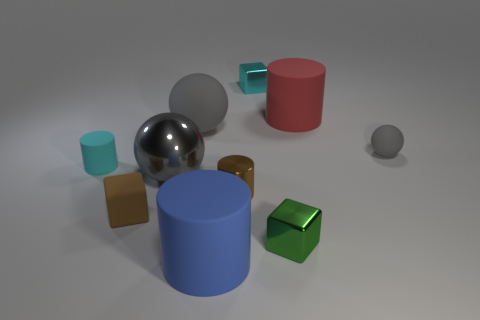There is a rubber cube that is the same color as the small metal cylinder; what size is it?
Offer a very short reply. Small. There is a tiny matte object that is the same color as the shiny cylinder; what shape is it?
Ensure brevity in your answer.  Cube. There is a gray ball that is right of the large cylinder to the left of the tiny brown metallic cylinder; are there any small metallic things that are behind it?
Provide a succinct answer. Yes. There is a red matte object that is the same size as the blue rubber cylinder; what shape is it?
Your response must be concise. Cylinder. Is there a rubber ball of the same color as the tiny matte cylinder?
Offer a very short reply. No. Is the shape of the tiny brown shiny thing the same as the tiny brown rubber object?
Provide a short and direct response. No. What number of large objects are either metallic blocks or blue cylinders?
Your response must be concise. 1. What color is the tiny ball that is made of the same material as the tiny cyan cylinder?
Ensure brevity in your answer.  Gray. How many purple cubes are made of the same material as the green cube?
Keep it short and to the point. 0. There is a metal object behind the metal ball; is it the same size as the gray matte ball on the right side of the tiny metal cylinder?
Your answer should be very brief. Yes. 